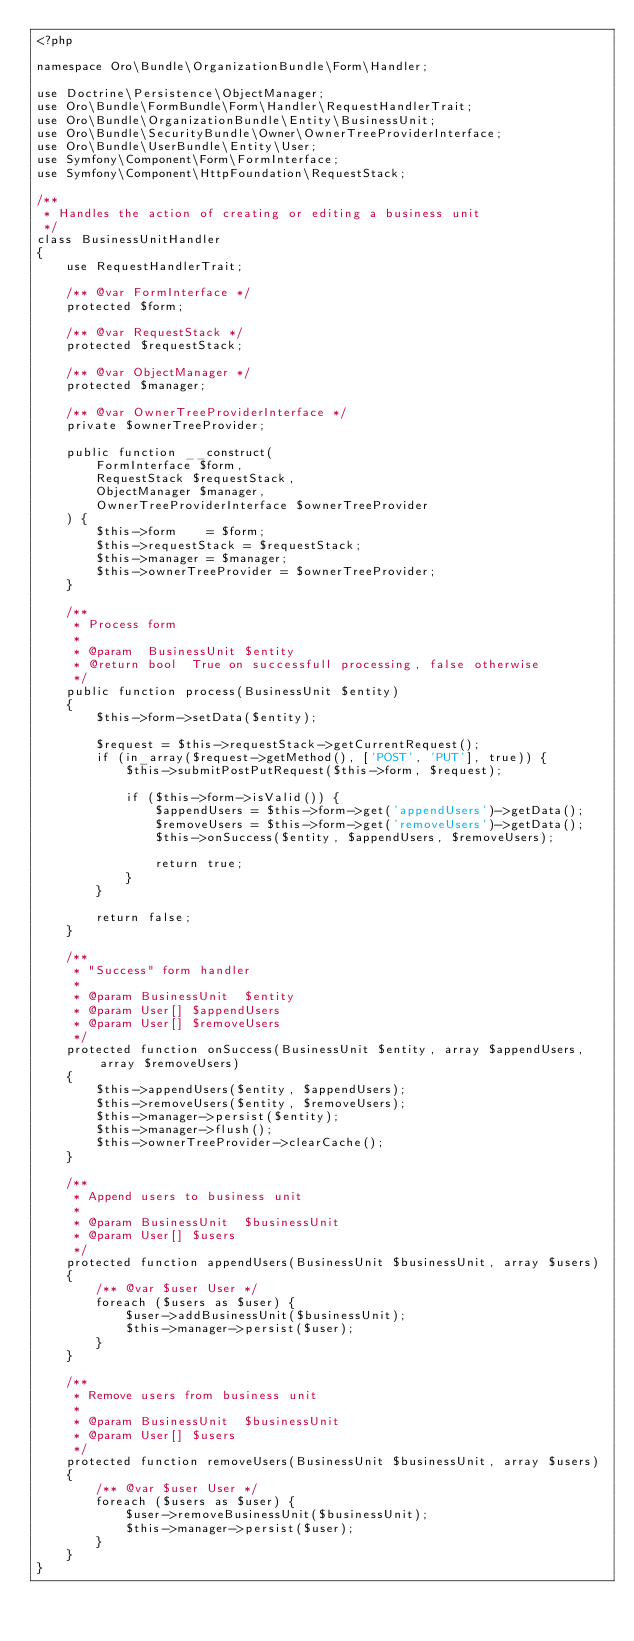<code> <loc_0><loc_0><loc_500><loc_500><_PHP_><?php

namespace Oro\Bundle\OrganizationBundle\Form\Handler;

use Doctrine\Persistence\ObjectManager;
use Oro\Bundle\FormBundle\Form\Handler\RequestHandlerTrait;
use Oro\Bundle\OrganizationBundle\Entity\BusinessUnit;
use Oro\Bundle\SecurityBundle\Owner\OwnerTreeProviderInterface;
use Oro\Bundle\UserBundle\Entity\User;
use Symfony\Component\Form\FormInterface;
use Symfony\Component\HttpFoundation\RequestStack;

/**
 * Handles the action of creating or editing a business unit
 */
class BusinessUnitHandler
{
    use RequestHandlerTrait;

    /** @var FormInterface */
    protected $form;

    /** @var RequestStack */
    protected $requestStack;

    /** @var ObjectManager */
    protected $manager;

    /** @var OwnerTreeProviderInterface */
    private $ownerTreeProvider;

    public function __construct(
        FormInterface $form,
        RequestStack $requestStack,
        ObjectManager $manager,
        OwnerTreeProviderInterface $ownerTreeProvider
    ) {
        $this->form    = $form;
        $this->requestStack = $requestStack;
        $this->manager = $manager;
        $this->ownerTreeProvider = $ownerTreeProvider;
    }

    /**
     * Process form
     *
     * @param  BusinessUnit $entity
     * @return bool  True on successfull processing, false otherwise
     */
    public function process(BusinessUnit $entity)
    {
        $this->form->setData($entity);

        $request = $this->requestStack->getCurrentRequest();
        if (in_array($request->getMethod(), ['POST', 'PUT'], true)) {
            $this->submitPostPutRequest($this->form, $request);

            if ($this->form->isValid()) {
                $appendUsers = $this->form->get('appendUsers')->getData();
                $removeUsers = $this->form->get('removeUsers')->getData();
                $this->onSuccess($entity, $appendUsers, $removeUsers);

                return true;
            }
        }

        return false;
    }

    /**
     * "Success" form handler
     *
     * @param BusinessUnit  $entity
     * @param User[] $appendUsers
     * @param User[] $removeUsers
     */
    protected function onSuccess(BusinessUnit $entity, array $appendUsers, array $removeUsers)
    {
        $this->appendUsers($entity, $appendUsers);
        $this->removeUsers($entity, $removeUsers);
        $this->manager->persist($entity);
        $this->manager->flush();
        $this->ownerTreeProvider->clearCache();
    }

    /**
     * Append users to business unit
     *
     * @param BusinessUnit  $businessUnit
     * @param User[] $users
     */
    protected function appendUsers(BusinessUnit $businessUnit, array $users)
    {
        /** @var $user User */
        foreach ($users as $user) {
            $user->addBusinessUnit($businessUnit);
            $this->manager->persist($user);
        }
    }

    /**
     * Remove users from business unit
     *
     * @param BusinessUnit  $businessUnit
     * @param User[] $users
     */
    protected function removeUsers(BusinessUnit $businessUnit, array $users)
    {
        /** @var $user User */
        foreach ($users as $user) {
            $user->removeBusinessUnit($businessUnit);
            $this->manager->persist($user);
        }
    }
}
</code> 